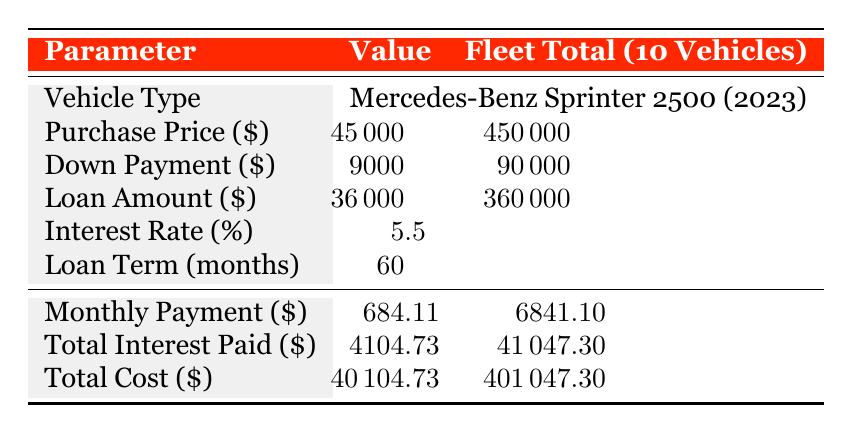What is the purchase price of one service van? The table states that the purchase price of one Mercedes-Benz Sprinter 2500 van is 45000.
Answer: 45000 How much is the down payment for the entire fleet of vehicles? The down payment for one vehicle is 9000, and since there are 10 vehicles, the total down payment is calculated as 9000 multiplied by 10, which equals 90000.
Answer: 90000 What is the total interest paid for one vehicle? According to the table, the total interest paid on one vehicle loan is 4104.73.
Answer: 4104.73 Is the loan interest rate higher than 5%? The table shows an interest rate of 5.5%, which is indeed higher than 5%. Therefore, the statement is true.
Answer: Yes What is the total monthly payment for the fleet? The monthly payment for one vehicle is 684.11. To find the total for the fleet, multiply 684.11 by 10, resulting in 6841.10.
Answer: 6841.10 If the total cost of one vehicle is 40104.73, what is the total cost for the fleet? To find the total cost for all 10 vehicles, multiply the total cost of one vehicle (40104.73) by 10, resulting in 401047.30.
Answer: 401047.30 What is the difference between the total loan amount and the total down payment for the fleet? The total loan amount for the fleet is 360000 and the total down payment is 90000, so the difference is 360000 minus 90000, which equals 270000.
Answer: 270000 Is the loan term longer than 48 months? The table indicates a loan term of 60 months, which is indeed longer than 48 months. Thus, the statement is true.
Answer: Yes How much is the total cost of interest for the entire fleet compared to the total cost of one vehicle? The total interest paid for the fleet is 41047.30 and the total cost of one vehicle is 40104.73. To compare, the interest for the fleet is significantly higher as it reflects 10 vehicles while the cost represents just one.
Answer: The fleet interest is higher 